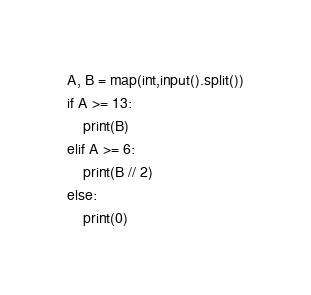Convert code to text. <code><loc_0><loc_0><loc_500><loc_500><_Python_>A, B = map(int,input().split())
if A >= 13:
    print(B)
elif A >= 6:
    print(B // 2)
else:
    print(0)</code> 